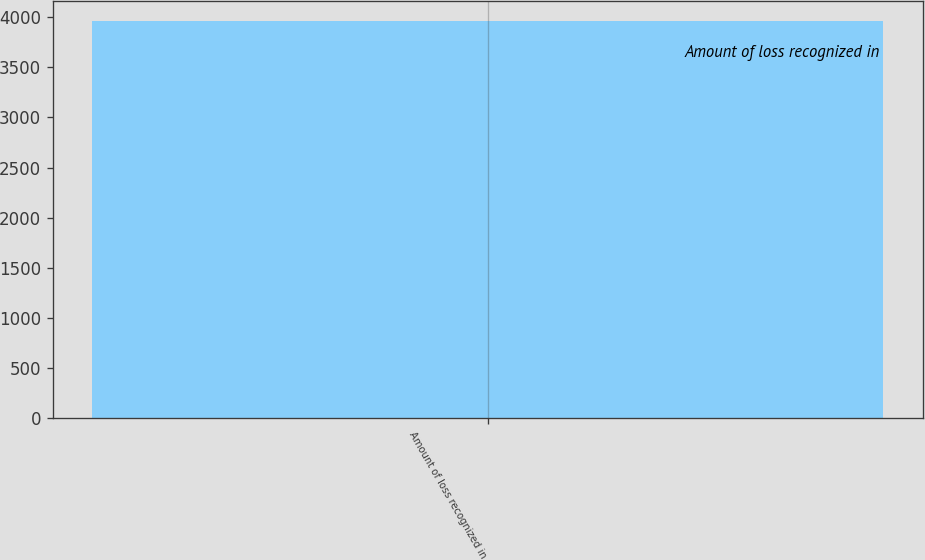Convert chart. <chart><loc_0><loc_0><loc_500><loc_500><bar_chart><fcel>Amount of loss recognized in<nl><fcel>3958<nl></chart> 